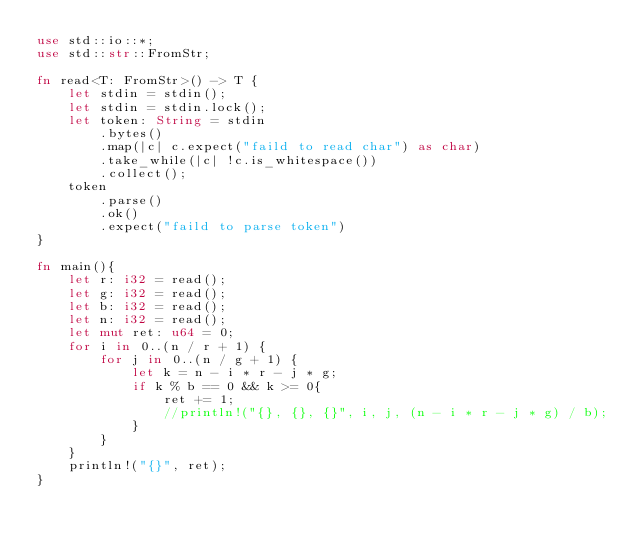<code> <loc_0><loc_0><loc_500><loc_500><_Rust_>use std::io::*;
use std::str::FromStr;

fn read<T: FromStr>() -> T {
    let stdin = stdin();
    let stdin = stdin.lock();
    let token: String = stdin
        .bytes()
        .map(|c| c.expect("faild to read char") as char)
        .take_while(|c| !c.is_whitespace())
        .collect();
    token
        .parse()
        .ok()
        .expect("faild to parse token")
}

fn main(){
    let r: i32 = read();
    let g: i32 = read();
    let b: i32 = read();
    let n: i32 = read();
    let mut ret: u64 = 0;
    for i in 0..(n / r + 1) {
        for j in 0..(n / g + 1) {
            let k = n - i * r - j * g;
            if k % b == 0 && k >= 0{
                ret += 1;
                //println!("{}, {}, {}", i, j, (n - i * r - j * g) / b);
            }
        }
    }
    println!("{}", ret);
}
</code> 